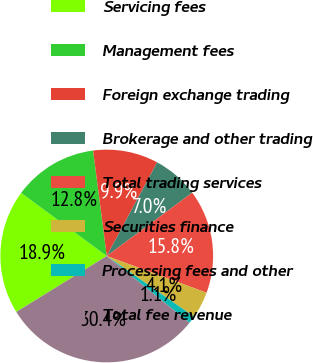<chart> <loc_0><loc_0><loc_500><loc_500><pie_chart><fcel>Servicing fees<fcel>Management fees<fcel>Foreign exchange trading<fcel>Brokerage and other trading<fcel>Total trading services<fcel>Securities finance<fcel>Processing fees and other<fcel>Total fee revenue<nl><fcel>18.92%<fcel>12.84%<fcel>9.91%<fcel>6.99%<fcel>15.76%<fcel>4.06%<fcel>1.14%<fcel>30.38%<nl></chart> 